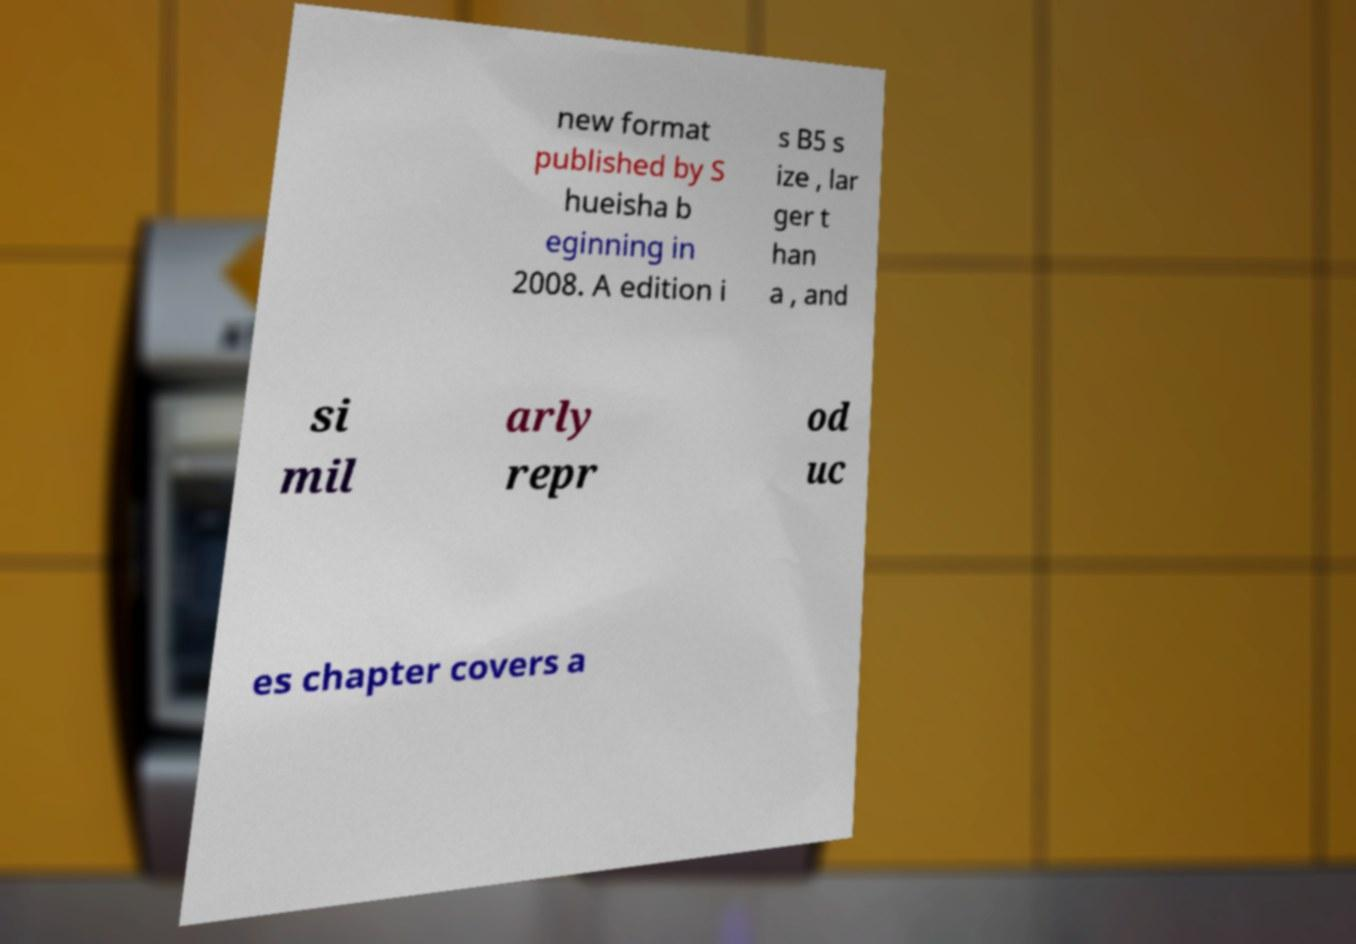Could you assist in decoding the text presented in this image and type it out clearly? new format published by S hueisha b eginning in 2008. A edition i s B5 s ize , lar ger t han a , and si mil arly repr od uc es chapter covers a 